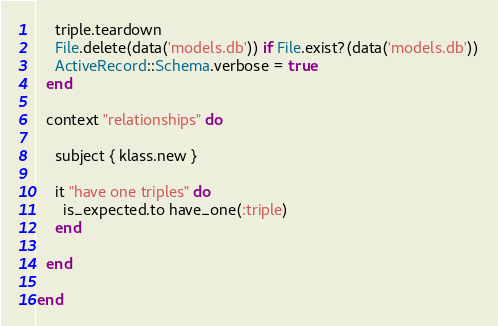Convert code to text. <code><loc_0><loc_0><loc_500><loc_500><_Ruby_>    triple.teardown
    File.delete(data('models.db')) if File.exist?(data('models.db'))
    ActiveRecord::Schema.verbose = true
  end

  context "relationships" do

    subject { klass.new }

    it "have one triples" do
      is_expected.to have_one(:triple)
    end

  end

end
</code> 